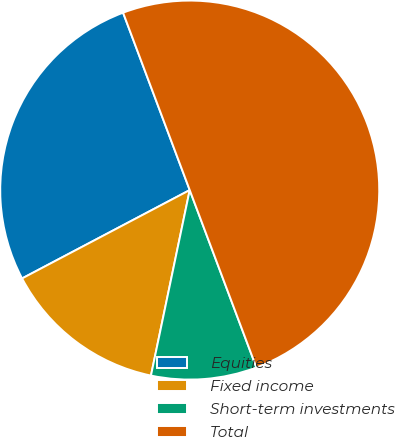Convert chart. <chart><loc_0><loc_0><loc_500><loc_500><pie_chart><fcel>Equities<fcel>Fixed income<fcel>Short-term investments<fcel>Total<nl><fcel>27.0%<fcel>14.0%<fcel>9.0%<fcel>50.0%<nl></chart> 